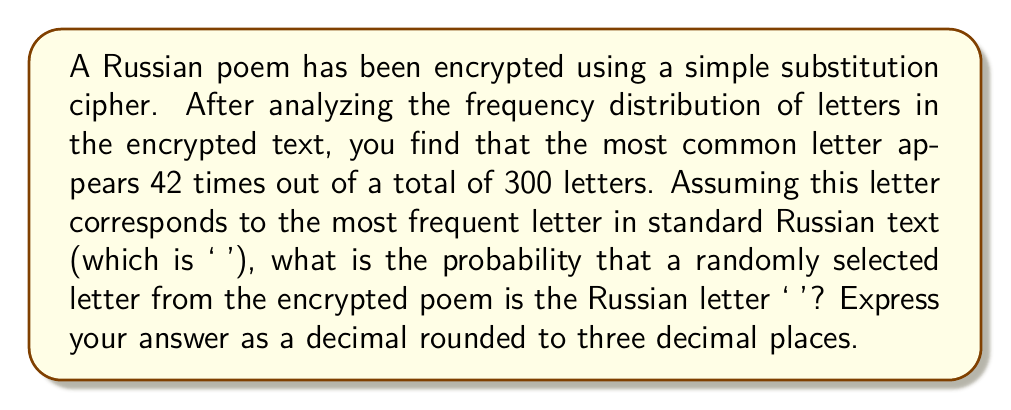Can you solve this math problem? To solve this problem, we need to follow these steps:

1. Identify the total number of letters and the frequency of the most common letter:
   - Total letters: 300
   - Occurrences of the most common letter: 42

2. Calculate the probability:
   The probability is the number of favorable outcomes divided by the total number of possible outcomes.

   $$P(\text{'о'}) = \frac{\text{Number of occurrences of 'о'}}{\text{Total number of letters}}$$

3. Substitute the values:

   $$P(\text{'о'}) = \frac{42}{300}$$

4. Perform the division:

   $$P(\text{'о'}) = 0.14$$

5. Round to three decimal places:
   The result is already rounded to three decimal places, so no further rounding is necessary.

Therefore, the probability that a randomly selected letter from the encrypted poem is the Russian letter 'о' is 0.140 or 14.0%.
Answer: 0.140 